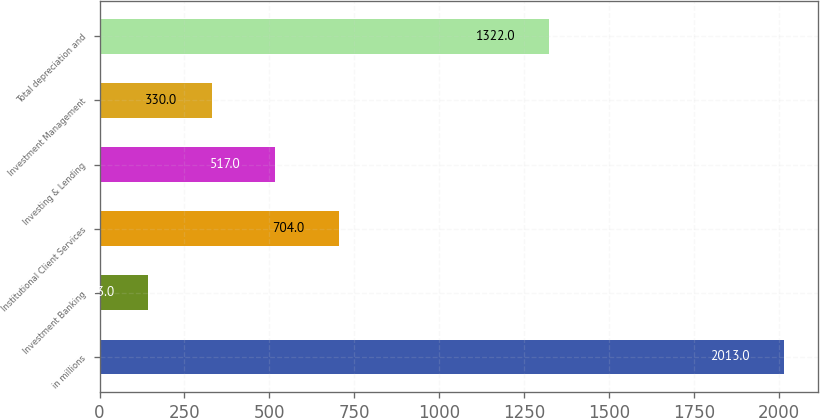Convert chart to OTSL. <chart><loc_0><loc_0><loc_500><loc_500><bar_chart><fcel>in millions<fcel>Investment Banking<fcel>Institutional Client Services<fcel>Investing & Lending<fcel>Investment Management<fcel>Total depreciation and<nl><fcel>2013<fcel>143<fcel>704<fcel>517<fcel>330<fcel>1322<nl></chart> 